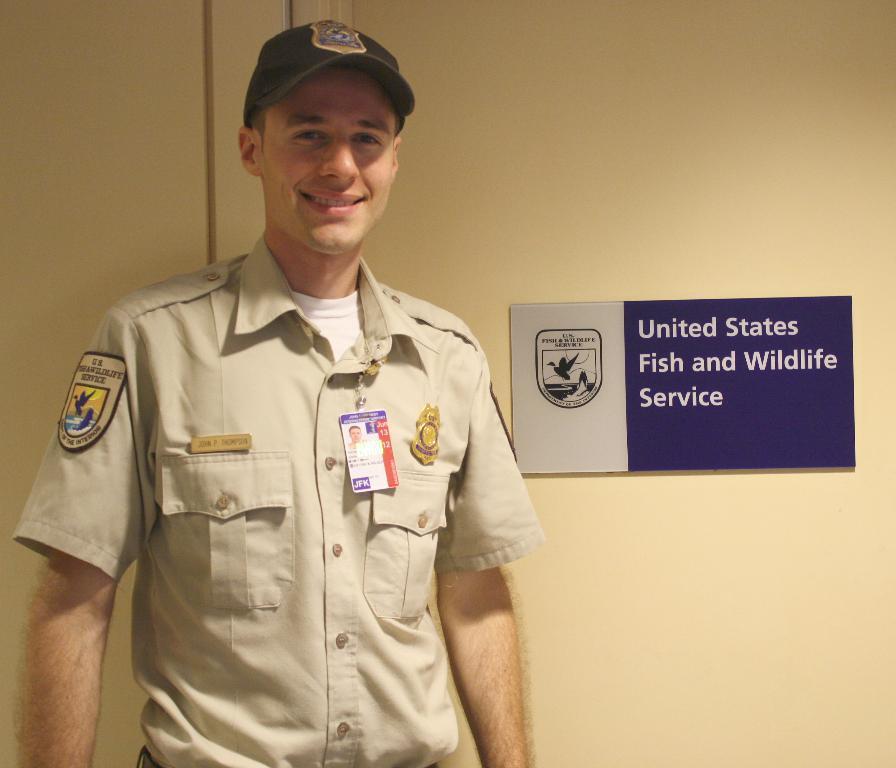How would you summarize this image in a sentence or two? Here we can see a man standing and smiling. In the background we can see a board on the wall. 